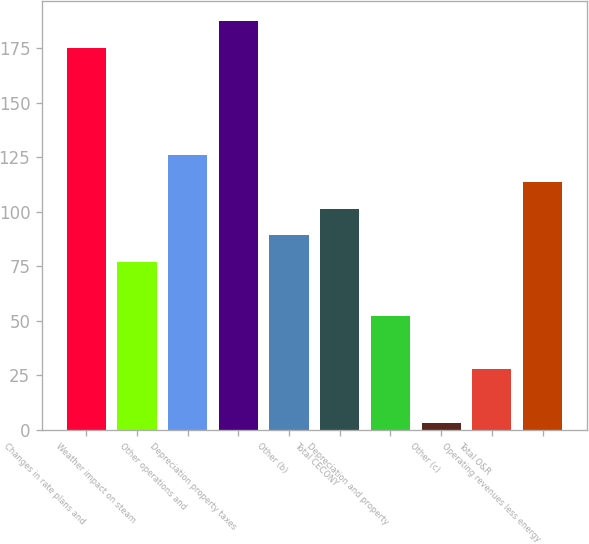Convert chart. <chart><loc_0><loc_0><loc_500><loc_500><bar_chart><fcel>Changes in rate plans and<fcel>Weather impact on steam<fcel>Other operations and<fcel>Depreciation property taxes<fcel>Other (b)<fcel>Total CECONY<fcel>Depreciation and property<fcel>Other (c)<fcel>Total O&R<fcel>Operating revenues less energy<nl><fcel>175.2<fcel>76.8<fcel>126<fcel>187.5<fcel>89.1<fcel>101.4<fcel>52.2<fcel>3<fcel>27.6<fcel>113.7<nl></chart> 